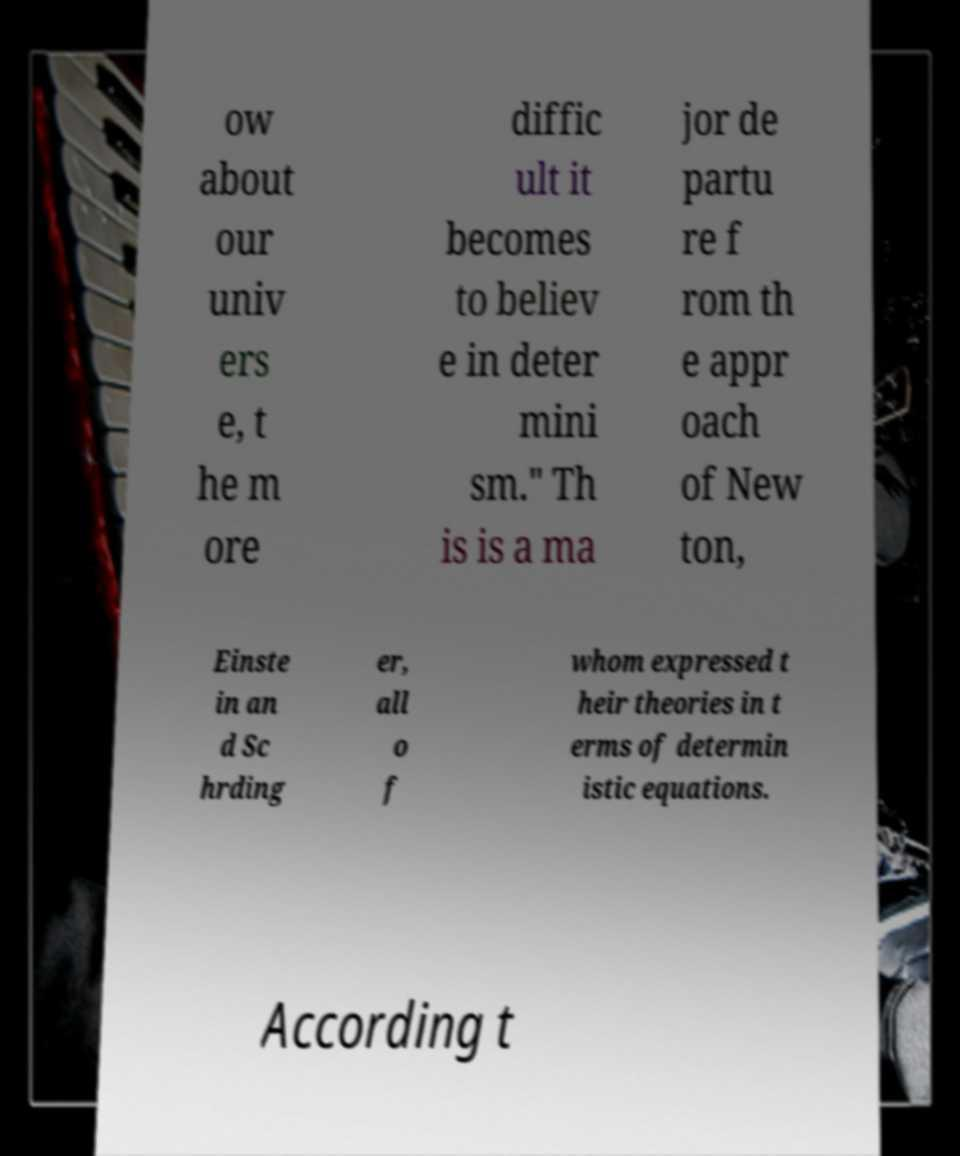Please identify and transcribe the text found in this image. ow about our univ ers e, t he m ore diffic ult it becomes to believ e in deter mini sm." Th is is a ma jor de partu re f rom th e appr oach of New ton, Einste in an d Sc hrding er, all o f whom expressed t heir theories in t erms of determin istic equations. According t 